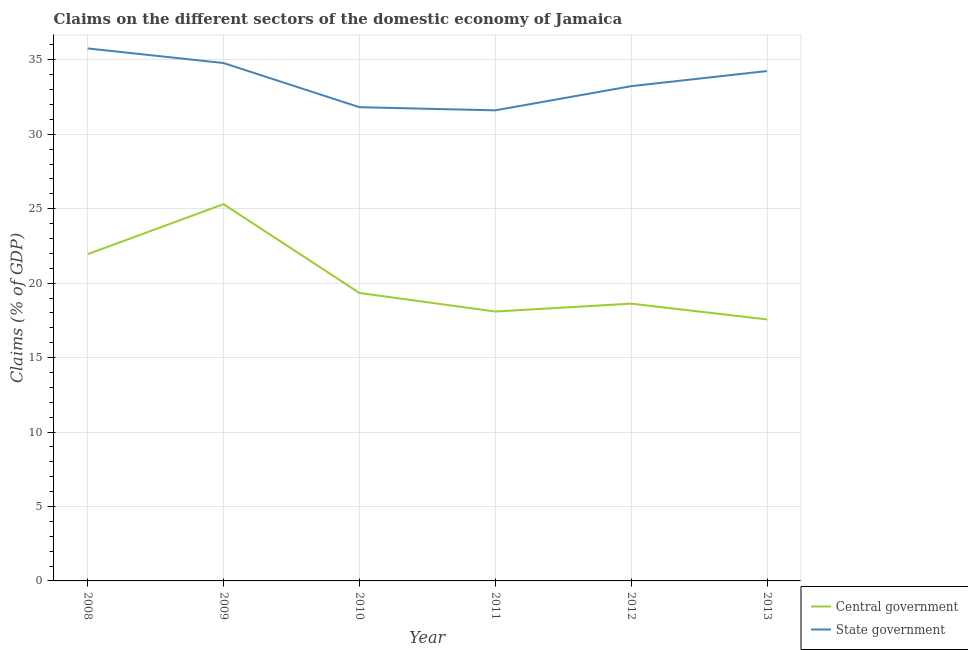How many different coloured lines are there?
Offer a very short reply. 2. Does the line corresponding to claims on central government intersect with the line corresponding to claims on state government?
Provide a succinct answer. No. What is the claims on state government in 2013?
Your response must be concise. 34.24. Across all years, what is the maximum claims on state government?
Offer a terse response. 35.76. Across all years, what is the minimum claims on state government?
Ensure brevity in your answer.  31.6. In which year was the claims on central government maximum?
Ensure brevity in your answer.  2009. What is the total claims on central government in the graph?
Your answer should be very brief. 120.86. What is the difference between the claims on state government in 2009 and that in 2012?
Keep it short and to the point. 1.55. What is the difference between the claims on state government in 2013 and the claims on central government in 2008?
Make the answer very short. 12.3. What is the average claims on central government per year?
Offer a terse response. 20.14. In the year 2011, what is the difference between the claims on central government and claims on state government?
Provide a short and direct response. -13.51. What is the ratio of the claims on central government in 2010 to that in 2012?
Keep it short and to the point. 1.04. Is the claims on state government in 2010 less than that in 2012?
Offer a terse response. Yes. What is the difference between the highest and the second highest claims on central government?
Your response must be concise. 3.36. What is the difference between the highest and the lowest claims on state government?
Give a very brief answer. 4.16. In how many years, is the claims on central government greater than the average claims on central government taken over all years?
Your response must be concise. 2. Is the sum of the claims on state government in 2008 and 2013 greater than the maximum claims on central government across all years?
Offer a terse response. Yes. Does the claims on state government monotonically increase over the years?
Keep it short and to the point. No. Is the claims on central government strictly greater than the claims on state government over the years?
Make the answer very short. No. Is the claims on central government strictly less than the claims on state government over the years?
Provide a short and direct response. Yes. What is the difference between two consecutive major ticks on the Y-axis?
Your answer should be compact. 5. How are the legend labels stacked?
Offer a very short reply. Vertical. What is the title of the graph?
Your answer should be compact. Claims on the different sectors of the domestic economy of Jamaica. What is the label or title of the X-axis?
Your response must be concise. Year. What is the label or title of the Y-axis?
Your answer should be compact. Claims (% of GDP). What is the Claims (% of GDP) in Central government in 2008?
Keep it short and to the point. 21.94. What is the Claims (% of GDP) of State government in 2008?
Your answer should be compact. 35.76. What is the Claims (% of GDP) of Central government in 2009?
Your response must be concise. 25.3. What is the Claims (% of GDP) of State government in 2009?
Your answer should be compact. 34.78. What is the Claims (% of GDP) of Central government in 2010?
Your answer should be compact. 19.34. What is the Claims (% of GDP) of State government in 2010?
Your answer should be very brief. 31.82. What is the Claims (% of GDP) in Central government in 2011?
Keep it short and to the point. 18.09. What is the Claims (% of GDP) in State government in 2011?
Make the answer very short. 31.6. What is the Claims (% of GDP) in Central government in 2012?
Your response must be concise. 18.62. What is the Claims (% of GDP) in State government in 2012?
Keep it short and to the point. 33.23. What is the Claims (% of GDP) of Central government in 2013?
Offer a terse response. 17.56. What is the Claims (% of GDP) in State government in 2013?
Provide a short and direct response. 34.24. Across all years, what is the maximum Claims (% of GDP) in Central government?
Ensure brevity in your answer.  25.3. Across all years, what is the maximum Claims (% of GDP) in State government?
Offer a terse response. 35.76. Across all years, what is the minimum Claims (% of GDP) in Central government?
Ensure brevity in your answer.  17.56. Across all years, what is the minimum Claims (% of GDP) of State government?
Provide a short and direct response. 31.6. What is the total Claims (% of GDP) in Central government in the graph?
Offer a terse response. 120.86. What is the total Claims (% of GDP) in State government in the graph?
Provide a short and direct response. 201.43. What is the difference between the Claims (% of GDP) in Central government in 2008 and that in 2009?
Your answer should be very brief. -3.36. What is the difference between the Claims (% of GDP) in State government in 2008 and that in 2009?
Your answer should be compact. 0.98. What is the difference between the Claims (% of GDP) of Central government in 2008 and that in 2010?
Give a very brief answer. 2.6. What is the difference between the Claims (% of GDP) of State government in 2008 and that in 2010?
Make the answer very short. 3.95. What is the difference between the Claims (% of GDP) in Central government in 2008 and that in 2011?
Keep it short and to the point. 3.85. What is the difference between the Claims (% of GDP) in State government in 2008 and that in 2011?
Provide a short and direct response. 4.16. What is the difference between the Claims (% of GDP) of Central government in 2008 and that in 2012?
Provide a short and direct response. 3.32. What is the difference between the Claims (% of GDP) in State government in 2008 and that in 2012?
Give a very brief answer. 2.53. What is the difference between the Claims (% of GDP) of Central government in 2008 and that in 2013?
Offer a terse response. 4.38. What is the difference between the Claims (% of GDP) in State government in 2008 and that in 2013?
Offer a terse response. 1.52. What is the difference between the Claims (% of GDP) of Central government in 2009 and that in 2010?
Give a very brief answer. 5.96. What is the difference between the Claims (% of GDP) of State government in 2009 and that in 2010?
Keep it short and to the point. 2.97. What is the difference between the Claims (% of GDP) in Central government in 2009 and that in 2011?
Your answer should be compact. 7.21. What is the difference between the Claims (% of GDP) of State government in 2009 and that in 2011?
Your answer should be compact. 3.18. What is the difference between the Claims (% of GDP) of Central government in 2009 and that in 2012?
Your answer should be very brief. 6.68. What is the difference between the Claims (% of GDP) in State government in 2009 and that in 2012?
Give a very brief answer. 1.55. What is the difference between the Claims (% of GDP) in Central government in 2009 and that in 2013?
Make the answer very short. 7.74. What is the difference between the Claims (% of GDP) in State government in 2009 and that in 2013?
Offer a very short reply. 0.54. What is the difference between the Claims (% of GDP) in Central government in 2010 and that in 2011?
Provide a short and direct response. 1.25. What is the difference between the Claims (% of GDP) of State government in 2010 and that in 2011?
Your answer should be compact. 0.21. What is the difference between the Claims (% of GDP) in Central government in 2010 and that in 2012?
Provide a succinct answer. 0.72. What is the difference between the Claims (% of GDP) in State government in 2010 and that in 2012?
Ensure brevity in your answer.  -1.41. What is the difference between the Claims (% of GDP) of Central government in 2010 and that in 2013?
Your answer should be compact. 1.78. What is the difference between the Claims (% of GDP) in State government in 2010 and that in 2013?
Your response must be concise. -2.43. What is the difference between the Claims (% of GDP) of Central government in 2011 and that in 2012?
Your response must be concise. -0.53. What is the difference between the Claims (% of GDP) in State government in 2011 and that in 2012?
Ensure brevity in your answer.  -1.62. What is the difference between the Claims (% of GDP) of Central government in 2011 and that in 2013?
Your answer should be compact. 0.53. What is the difference between the Claims (% of GDP) of State government in 2011 and that in 2013?
Your answer should be very brief. -2.64. What is the difference between the Claims (% of GDP) of Central government in 2012 and that in 2013?
Your answer should be very brief. 1.06. What is the difference between the Claims (% of GDP) in State government in 2012 and that in 2013?
Offer a very short reply. -1.02. What is the difference between the Claims (% of GDP) of Central government in 2008 and the Claims (% of GDP) of State government in 2009?
Provide a short and direct response. -12.84. What is the difference between the Claims (% of GDP) of Central government in 2008 and the Claims (% of GDP) of State government in 2010?
Your answer should be very brief. -9.87. What is the difference between the Claims (% of GDP) of Central government in 2008 and the Claims (% of GDP) of State government in 2011?
Give a very brief answer. -9.66. What is the difference between the Claims (% of GDP) in Central government in 2008 and the Claims (% of GDP) in State government in 2012?
Make the answer very short. -11.28. What is the difference between the Claims (% of GDP) of Central government in 2008 and the Claims (% of GDP) of State government in 2013?
Your response must be concise. -12.3. What is the difference between the Claims (% of GDP) in Central government in 2009 and the Claims (% of GDP) in State government in 2010?
Offer a very short reply. -6.51. What is the difference between the Claims (% of GDP) of Central government in 2009 and the Claims (% of GDP) of State government in 2011?
Ensure brevity in your answer.  -6.3. What is the difference between the Claims (% of GDP) in Central government in 2009 and the Claims (% of GDP) in State government in 2012?
Keep it short and to the point. -7.92. What is the difference between the Claims (% of GDP) of Central government in 2009 and the Claims (% of GDP) of State government in 2013?
Provide a short and direct response. -8.94. What is the difference between the Claims (% of GDP) of Central government in 2010 and the Claims (% of GDP) of State government in 2011?
Ensure brevity in your answer.  -12.26. What is the difference between the Claims (% of GDP) of Central government in 2010 and the Claims (% of GDP) of State government in 2012?
Provide a succinct answer. -13.89. What is the difference between the Claims (% of GDP) in Central government in 2010 and the Claims (% of GDP) in State government in 2013?
Make the answer very short. -14.9. What is the difference between the Claims (% of GDP) of Central government in 2011 and the Claims (% of GDP) of State government in 2012?
Offer a very short reply. -15.14. What is the difference between the Claims (% of GDP) in Central government in 2011 and the Claims (% of GDP) in State government in 2013?
Provide a short and direct response. -16.15. What is the difference between the Claims (% of GDP) of Central government in 2012 and the Claims (% of GDP) of State government in 2013?
Your answer should be compact. -15.62. What is the average Claims (% of GDP) of Central government per year?
Give a very brief answer. 20.14. What is the average Claims (% of GDP) of State government per year?
Your answer should be compact. 33.57. In the year 2008, what is the difference between the Claims (% of GDP) of Central government and Claims (% of GDP) of State government?
Provide a short and direct response. -13.82. In the year 2009, what is the difference between the Claims (% of GDP) of Central government and Claims (% of GDP) of State government?
Make the answer very short. -9.48. In the year 2010, what is the difference between the Claims (% of GDP) in Central government and Claims (% of GDP) in State government?
Your answer should be very brief. -12.48. In the year 2011, what is the difference between the Claims (% of GDP) of Central government and Claims (% of GDP) of State government?
Give a very brief answer. -13.51. In the year 2012, what is the difference between the Claims (% of GDP) in Central government and Claims (% of GDP) in State government?
Your response must be concise. -14.61. In the year 2013, what is the difference between the Claims (% of GDP) in Central government and Claims (% of GDP) in State government?
Offer a very short reply. -16.68. What is the ratio of the Claims (% of GDP) in Central government in 2008 to that in 2009?
Give a very brief answer. 0.87. What is the ratio of the Claims (% of GDP) in State government in 2008 to that in 2009?
Ensure brevity in your answer.  1.03. What is the ratio of the Claims (% of GDP) in Central government in 2008 to that in 2010?
Make the answer very short. 1.13. What is the ratio of the Claims (% of GDP) in State government in 2008 to that in 2010?
Provide a short and direct response. 1.12. What is the ratio of the Claims (% of GDP) of Central government in 2008 to that in 2011?
Ensure brevity in your answer.  1.21. What is the ratio of the Claims (% of GDP) of State government in 2008 to that in 2011?
Ensure brevity in your answer.  1.13. What is the ratio of the Claims (% of GDP) in Central government in 2008 to that in 2012?
Give a very brief answer. 1.18. What is the ratio of the Claims (% of GDP) of State government in 2008 to that in 2012?
Provide a succinct answer. 1.08. What is the ratio of the Claims (% of GDP) of Central government in 2008 to that in 2013?
Your answer should be very brief. 1.25. What is the ratio of the Claims (% of GDP) of State government in 2008 to that in 2013?
Provide a succinct answer. 1.04. What is the ratio of the Claims (% of GDP) of Central government in 2009 to that in 2010?
Offer a very short reply. 1.31. What is the ratio of the Claims (% of GDP) of State government in 2009 to that in 2010?
Make the answer very short. 1.09. What is the ratio of the Claims (% of GDP) of Central government in 2009 to that in 2011?
Your answer should be very brief. 1.4. What is the ratio of the Claims (% of GDP) in State government in 2009 to that in 2011?
Provide a short and direct response. 1.1. What is the ratio of the Claims (% of GDP) of Central government in 2009 to that in 2012?
Your response must be concise. 1.36. What is the ratio of the Claims (% of GDP) in State government in 2009 to that in 2012?
Your answer should be very brief. 1.05. What is the ratio of the Claims (% of GDP) of Central government in 2009 to that in 2013?
Keep it short and to the point. 1.44. What is the ratio of the Claims (% of GDP) in State government in 2009 to that in 2013?
Offer a terse response. 1.02. What is the ratio of the Claims (% of GDP) in Central government in 2010 to that in 2011?
Make the answer very short. 1.07. What is the ratio of the Claims (% of GDP) in State government in 2010 to that in 2011?
Your answer should be compact. 1.01. What is the ratio of the Claims (% of GDP) of Central government in 2010 to that in 2012?
Your response must be concise. 1.04. What is the ratio of the Claims (% of GDP) of State government in 2010 to that in 2012?
Offer a very short reply. 0.96. What is the ratio of the Claims (% of GDP) of Central government in 2010 to that in 2013?
Provide a short and direct response. 1.1. What is the ratio of the Claims (% of GDP) in State government in 2010 to that in 2013?
Provide a short and direct response. 0.93. What is the ratio of the Claims (% of GDP) in Central government in 2011 to that in 2012?
Offer a terse response. 0.97. What is the ratio of the Claims (% of GDP) in State government in 2011 to that in 2012?
Your response must be concise. 0.95. What is the ratio of the Claims (% of GDP) in Central government in 2011 to that in 2013?
Keep it short and to the point. 1.03. What is the ratio of the Claims (% of GDP) in State government in 2011 to that in 2013?
Make the answer very short. 0.92. What is the ratio of the Claims (% of GDP) of Central government in 2012 to that in 2013?
Keep it short and to the point. 1.06. What is the ratio of the Claims (% of GDP) in State government in 2012 to that in 2013?
Provide a short and direct response. 0.97. What is the difference between the highest and the second highest Claims (% of GDP) of Central government?
Provide a succinct answer. 3.36. What is the difference between the highest and the second highest Claims (% of GDP) in State government?
Your answer should be compact. 0.98. What is the difference between the highest and the lowest Claims (% of GDP) in Central government?
Your response must be concise. 7.74. What is the difference between the highest and the lowest Claims (% of GDP) of State government?
Provide a short and direct response. 4.16. 